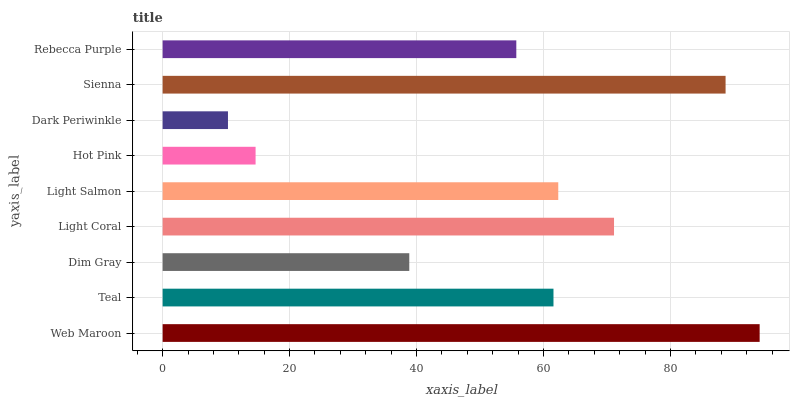Is Dark Periwinkle the minimum?
Answer yes or no. Yes. Is Web Maroon the maximum?
Answer yes or no. Yes. Is Teal the minimum?
Answer yes or no. No. Is Teal the maximum?
Answer yes or no. No. Is Web Maroon greater than Teal?
Answer yes or no. Yes. Is Teal less than Web Maroon?
Answer yes or no. Yes. Is Teal greater than Web Maroon?
Answer yes or no. No. Is Web Maroon less than Teal?
Answer yes or no. No. Is Teal the high median?
Answer yes or no. Yes. Is Teal the low median?
Answer yes or no. Yes. Is Light Coral the high median?
Answer yes or no. No. Is Hot Pink the low median?
Answer yes or no. No. 